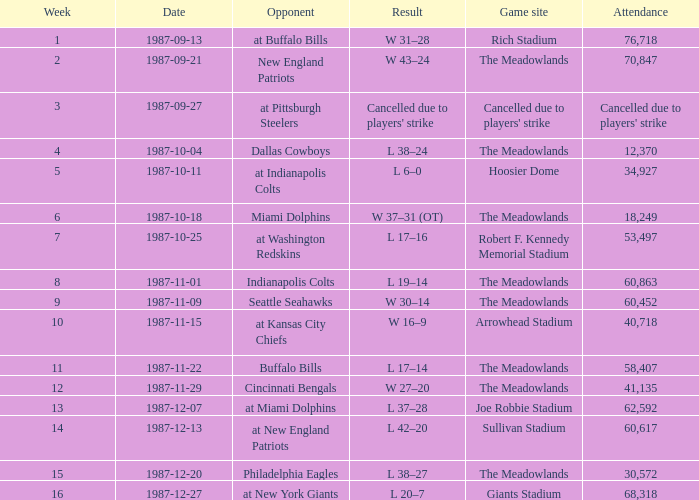Who did the Jets play in their post-week 15 game? At new york giants. 